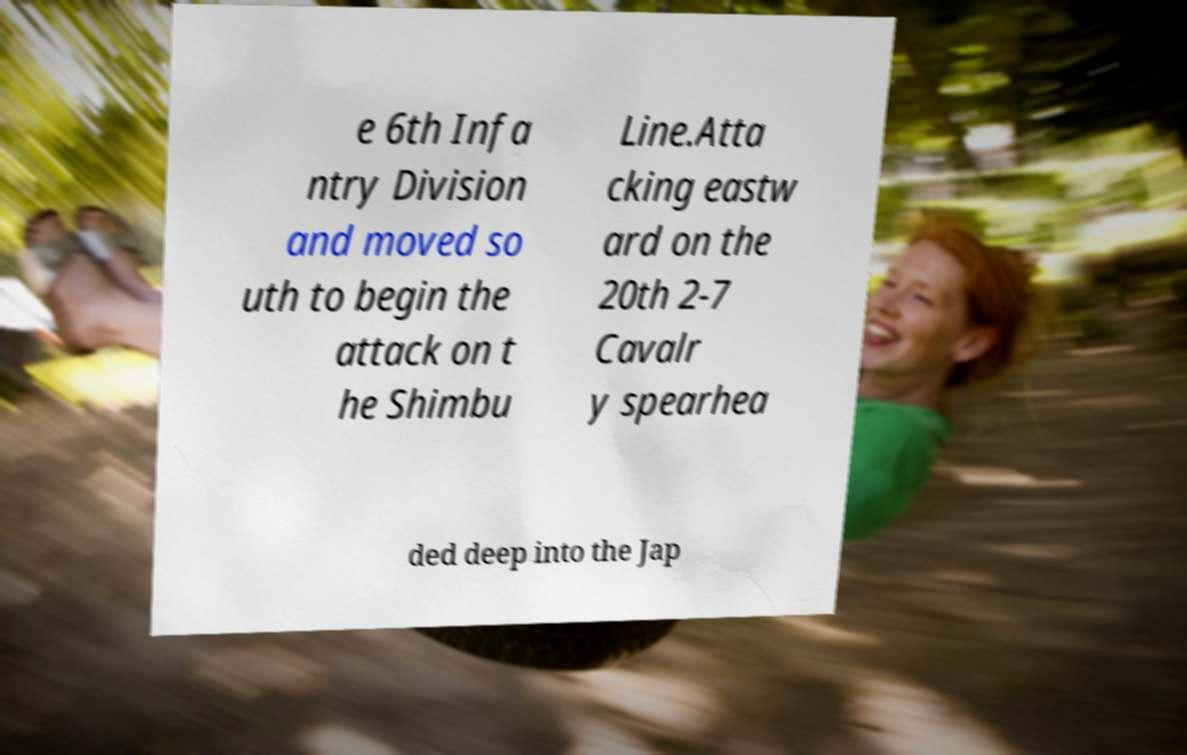Can you read and provide the text displayed in the image?This photo seems to have some interesting text. Can you extract and type it out for me? e 6th Infa ntry Division and moved so uth to begin the attack on t he Shimbu Line.Atta cking eastw ard on the 20th 2-7 Cavalr y spearhea ded deep into the Jap 